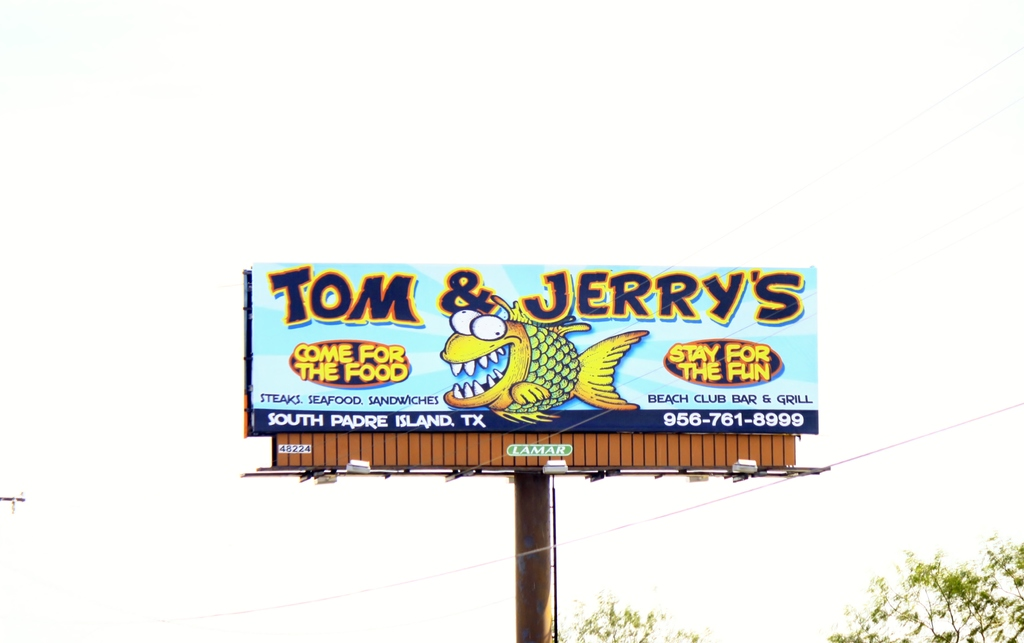What are some reasons someone might choose to dine at Tom & Jerry's? Someone might choose to dine at Tom & Jerry's for its diverse menu options like steaks, seafood, and sandwiches, catering to varying tastes and preferences. Additionally, the slogan 'Stay for the fun' suggests an engaging experience beyond just dining, such as possibly live music or themed nights, making it a comprehensive entertainment spot. Are there special events or entertainment provided at this venue? While the billboard doesn't specify, the emphasis on 'fun' might hint at special events or entertainment options like live bands, DJ nights, or karaoke, common in beach club bars and grills to attract a robust crowd and create memorable experiences. 